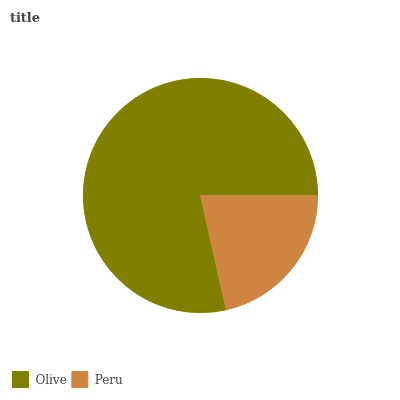Is Peru the minimum?
Answer yes or no. Yes. Is Olive the maximum?
Answer yes or no. Yes. Is Peru the maximum?
Answer yes or no. No. Is Olive greater than Peru?
Answer yes or no. Yes. Is Peru less than Olive?
Answer yes or no. Yes. Is Peru greater than Olive?
Answer yes or no. No. Is Olive less than Peru?
Answer yes or no. No. Is Olive the high median?
Answer yes or no. Yes. Is Peru the low median?
Answer yes or no. Yes. Is Peru the high median?
Answer yes or no. No. Is Olive the low median?
Answer yes or no. No. 